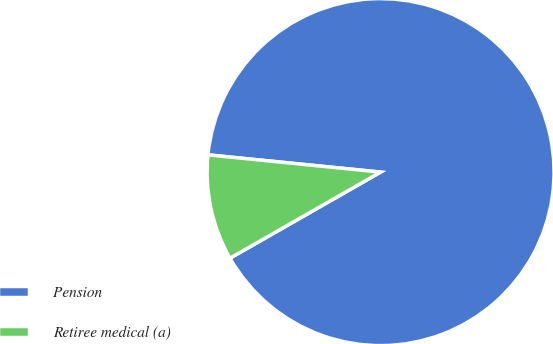<chart> <loc_0><loc_0><loc_500><loc_500><pie_chart><fcel>Pension<fcel>Retiree medical (a)<nl><fcel>90.15%<fcel>9.85%<nl></chart> 